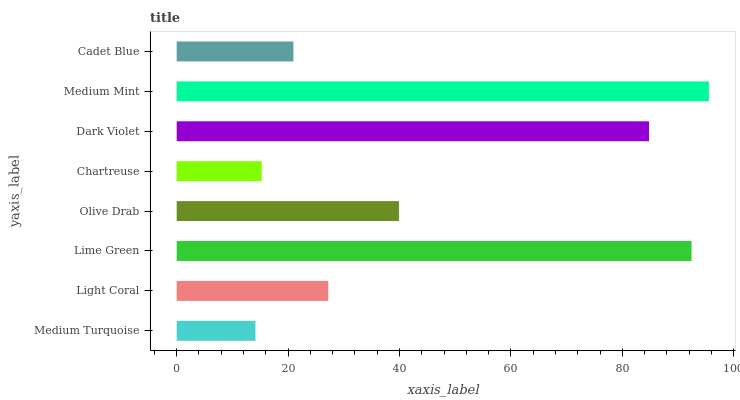Is Medium Turquoise the minimum?
Answer yes or no. Yes. Is Medium Mint the maximum?
Answer yes or no. Yes. Is Light Coral the minimum?
Answer yes or no. No. Is Light Coral the maximum?
Answer yes or no. No. Is Light Coral greater than Medium Turquoise?
Answer yes or no. Yes. Is Medium Turquoise less than Light Coral?
Answer yes or no. Yes. Is Medium Turquoise greater than Light Coral?
Answer yes or no. No. Is Light Coral less than Medium Turquoise?
Answer yes or no. No. Is Olive Drab the high median?
Answer yes or no. Yes. Is Light Coral the low median?
Answer yes or no. Yes. Is Chartreuse the high median?
Answer yes or no. No. Is Dark Violet the low median?
Answer yes or no. No. 